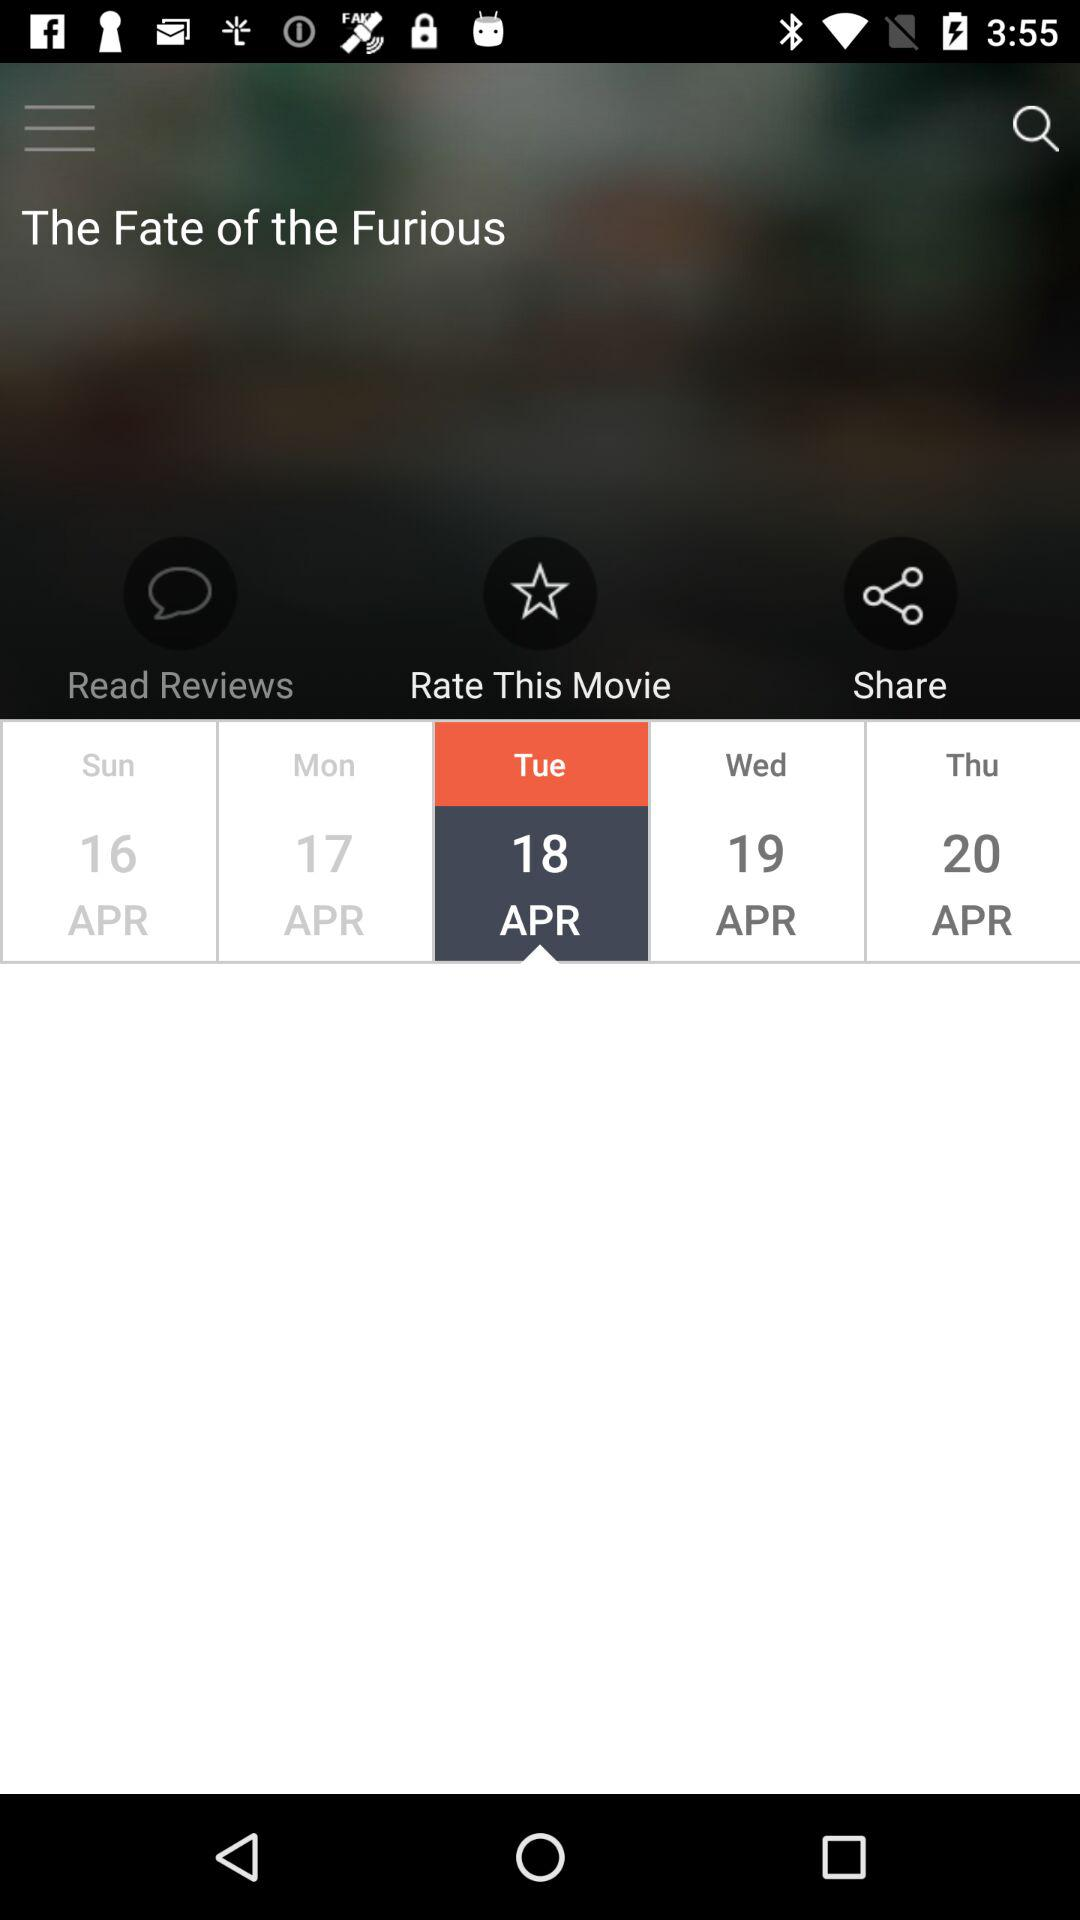What is the day on April 18? The day is Tuesday. 